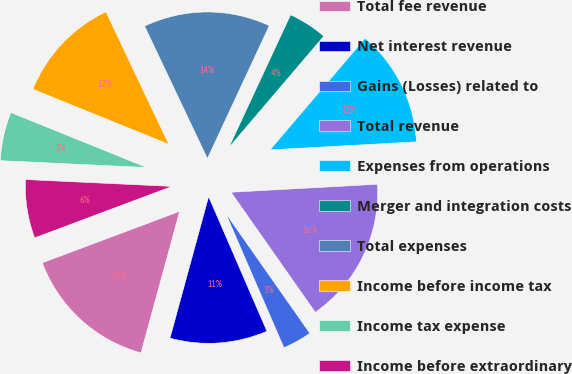<chart> <loc_0><loc_0><loc_500><loc_500><pie_chart><fcel>Total fee revenue<fcel>Net interest revenue<fcel>Gains (Losses) related to<fcel>Total revenue<fcel>Expenses from operations<fcel>Merger and integration costs<fcel>Total expenses<fcel>Income before income tax<fcel>Income tax expense<fcel>Income before extraordinary<nl><fcel>15.05%<fcel>10.75%<fcel>3.23%<fcel>16.13%<fcel>12.9%<fcel>4.3%<fcel>13.98%<fcel>11.83%<fcel>5.38%<fcel>6.45%<nl></chart> 